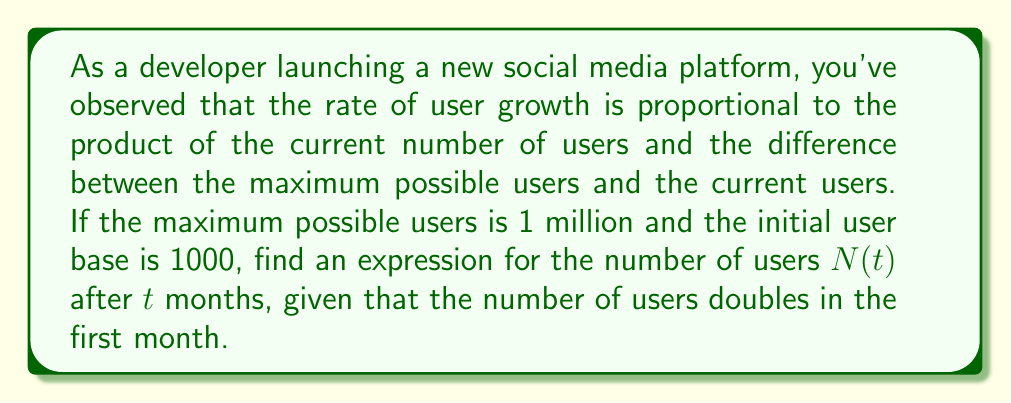Provide a solution to this math problem. Let's approach this step-by-step:

1) First, we need to set up our differential equation. Let $N(t)$ be the number of users at time $t$ (in months). The rate of change is given by:

   $$\frac{dN}{dt} = kN(M-N)$$

   where $k$ is a constant and $M$ is the maximum number of users.

2) We're given that $M = 1,000,000$ and $N(0) = 1000$.

3) To find $k$, we can use the information that the number of users doubles in the first month:

   $N(1) = 2000$

4) The general solution to this logistic differential equation is:

   $$N(t) = \frac{M}{1 + Ce^{-kMt}}$$

   where $C$ is a constant we need to determine.

5) Using the initial condition $N(0) = 1000$:

   $$1000 = \frac{1000000}{1 + C}$$

   Solving for $C$:
   
   $$C = 999$$

6) Now we can use the condition $N(1) = 2000$ to find $k$:

   $$2000 = \frac{1000000}{1 + 999e^{-1000000k}}$$

   Solving this equation:

   $$k \approx 6.93 \times 10^{-7}$$

7) Therefore, our final solution is:

   $$N(t) = \frac{1000000}{1 + 999e^{-0.693t}}$$
Answer: $N(t) = \frac{1000000}{1 + 999e^{-0.693t}}$ 